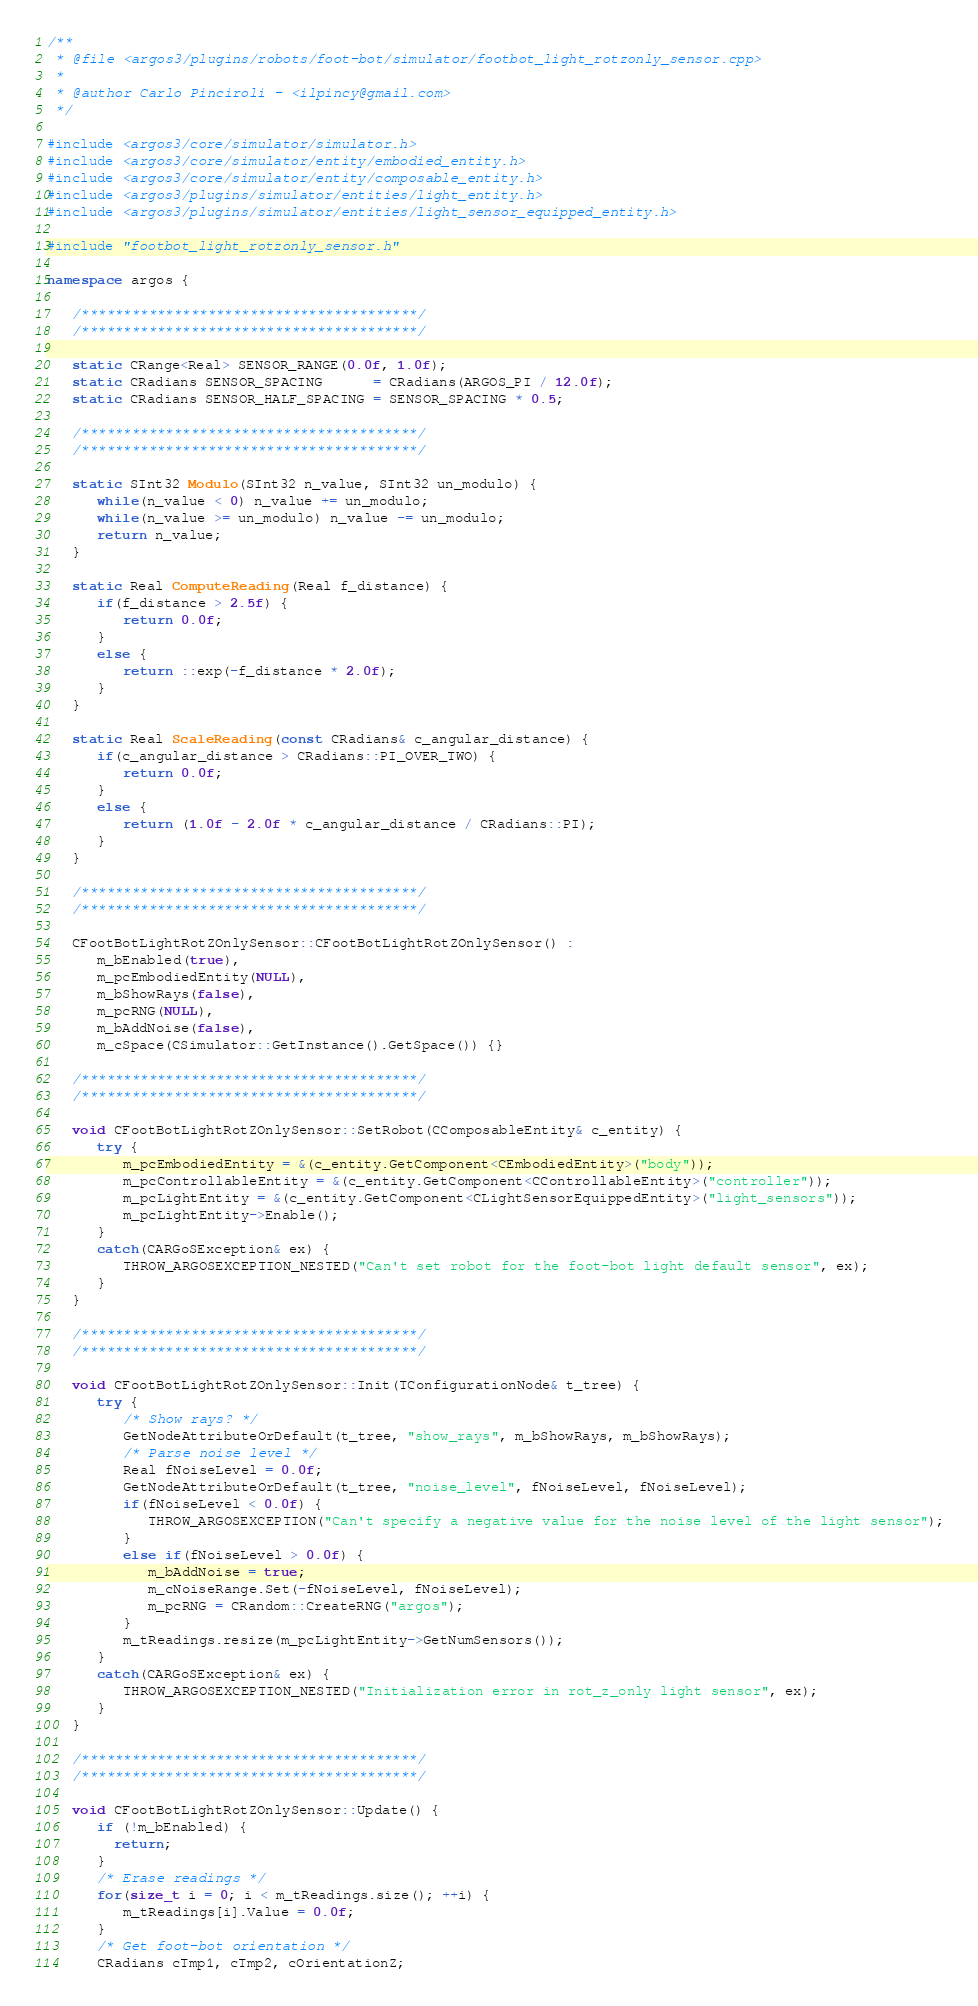Convert code to text. <code><loc_0><loc_0><loc_500><loc_500><_C++_>/**
 * @file <argos3/plugins/robots/foot-bot/simulator/footbot_light_rotzonly_sensor.cpp>
 *
 * @author Carlo Pinciroli - <ilpincy@gmail.com>
 */

#include <argos3/core/simulator/simulator.h>
#include <argos3/core/simulator/entity/embodied_entity.h>
#include <argos3/core/simulator/entity/composable_entity.h>
#include <argos3/plugins/simulator/entities/light_entity.h>
#include <argos3/plugins/simulator/entities/light_sensor_equipped_entity.h>

#include "footbot_light_rotzonly_sensor.h"

namespace argos {

   /****************************************/
   /****************************************/

   static CRange<Real> SENSOR_RANGE(0.0f, 1.0f);
   static CRadians SENSOR_SPACING      = CRadians(ARGOS_PI / 12.0f);
   static CRadians SENSOR_HALF_SPACING = SENSOR_SPACING * 0.5;

   /****************************************/
   /****************************************/

   static SInt32 Modulo(SInt32 n_value, SInt32 un_modulo) {
      while(n_value < 0) n_value += un_modulo;
      while(n_value >= un_modulo) n_value -= un_modulo;
      return n_value;
   }

   static Real ComputeReading(Real f_distance) {
      if(f_distance > 2.5f) {
         return 0.0f;
      }
      else {
         return ::exp(-f_distance * 2.0f);
      }
   }

   static Real ScaleReading(const CRadians& c_angular_distance) {
      if(c_angular_distance > CRadians::PI_OVER_TWO) {
         return 0.0f;
      }
      else {
         return (1.0f - 2.0f * c_angular_distance / CRadians::PI);
      }
   }

   /****************************************/
   /****************************************/

   CFootBotLightRotZOnlySensor::CFootBotLightRotZOnlySensor() :
      m_bEnabled(true),
      m_pcEmbodiedEntity(NULL),
      m_bShowRays(false),
      m_pcRNG(NULL),
      m_bAddNoise(false),
      m_cSpace(CSimulator::GetInstance().GetSpace()) {}

   /****************************************/
   /****************************************/

   void CFootBotLightRotZOnlySensor::SetRobot(CComposableEntity& c_entity) {
      try {
         m_pcEmbodiedEntity = &(c_entity.GetComponent<CEmbodiedEntity>("body"));
         m_pcControllableEntity = &(c_entity.GetComponent<CControllableEntity>("controller"));
         m_pcLightEntity = &(c_entity.GetComponent<CLightSensorEquippedEntity>("light_sensors"));
         m_pcLightEntity->Enable();
      }
      catch(CARGoSException& ex) {
         THROW_ARGOSEXCEPTION_NESTED("Can't set robot for the foot-bot light default sensor", ex);
      }
   }

   /****************************************/
   /****************************************/

   void CFootBotLightRotZOnlySensor::Init(TConfigurationNode& t_tree) {
      try {
         /* Show rays? */
         GetNodeAttributeOrDefault(t_tree, "show_rays", m_bShowRays, m_bShowRays);
         /* Parse noise level */
         Real fNoiseLevel = 0.0f;
         GetNodeAttributeOrDefault(t_tree, "noise_level", fNoiseLevel, fNoiseLevel);
         if(fNoiseLevel < 0.0f) {
            THROW_ARGOSEXCEPTION("Can't specify a negative value for the noise level of the light sensor");
         }
         else if(fNoiseLevel > 0.0f) {
            m_bAddNoise = true;
            m_cNoiseRange.Set(-fNoiseLevel, fNoiseLevel);
            m_pcRNG = CRandom::CreateRNG("argos");
         }
         m_tReadings.resize(m_pcLightEntity->GetNumSensors());
      }
      catch(CARGoSException& ex) {
         THROW_ARGOSEXCEPTION_NESTED("Initialization error in rot_z_only light sensor", ex);
      }
   }

   /****************************************/
   /****************************************/
   
   void CFootBotLightRotZOnlySensor::Update() {
      if (!m_bEnabled) {
        return;
      }
      /* Erase readings */
      for(size_t i = 0; i < m_tReadings.size(); ++i) {
         m_tReadings[i].Value = 0.0f;
      }
      /* Get foot-bot orientation */
      CRadians cTmp1, cTmp2, cOrientationZ;</code> 